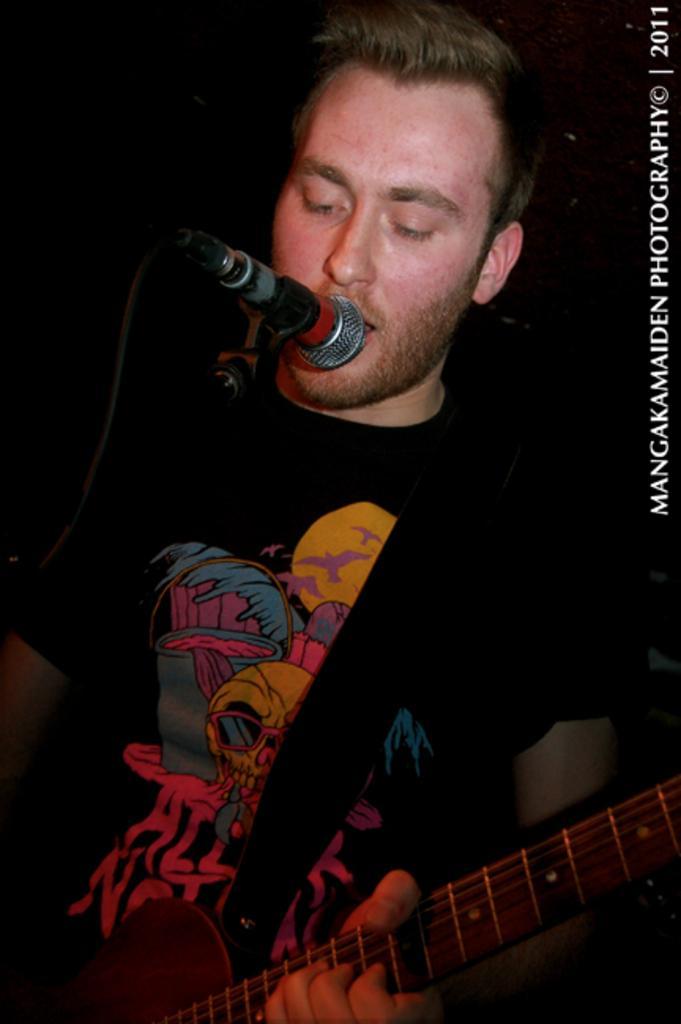Can you describe this image briefly? In this picture there is a boy who is singing in the mic which is placed in front of him by holding the guitar in his hands. 